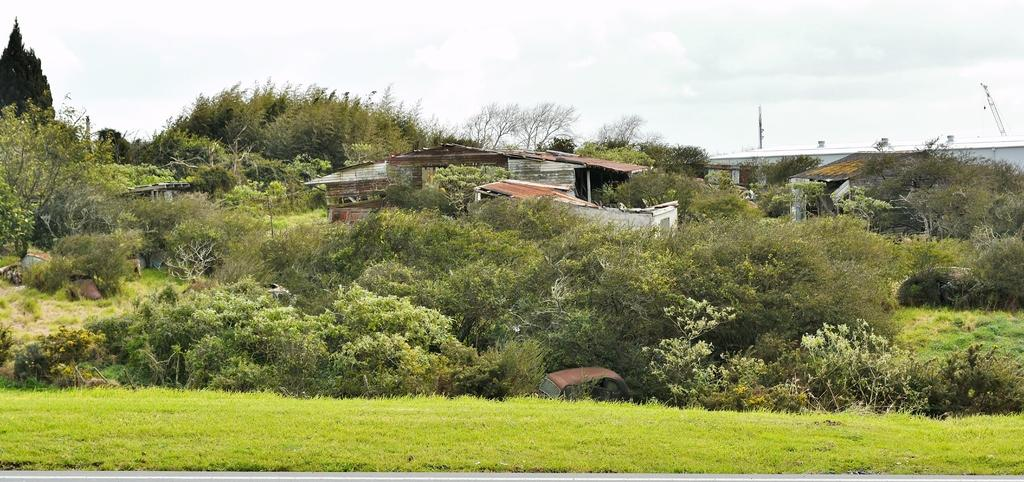What type of vegetation can be seen in the image? There are trees and plants in the image. What structures are present in the image? There are sheds in the image. What part of the natural environment is visible at the bottom of the image? The ground is visible at the bottom of the image. Can you hear the trees laughing in the image? Trees do not have the ability to laugh, so there is no laughter in the image. What type of clover can be seen growing near the sheds in the image? There is no clover present in the image; it features trees, plants, and sheds. 